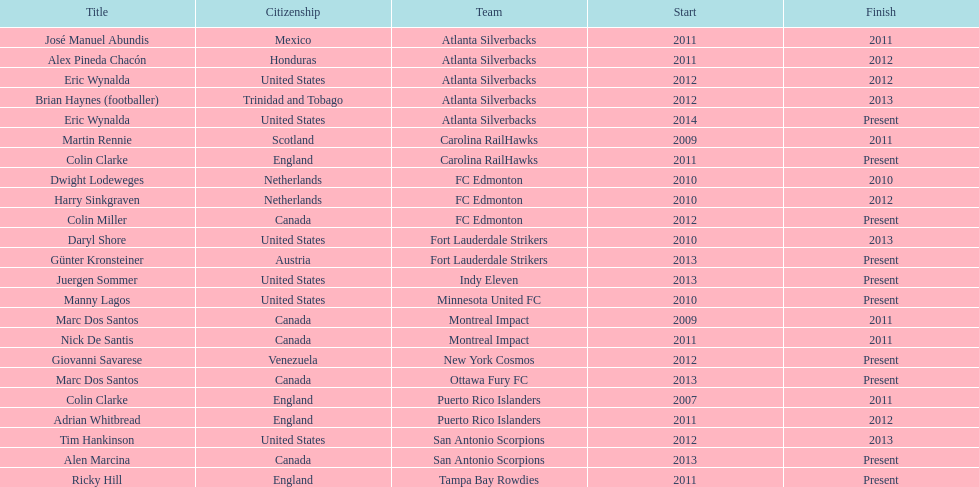Who is the last to coach the san antonio scorpions? Alen Marcina. 